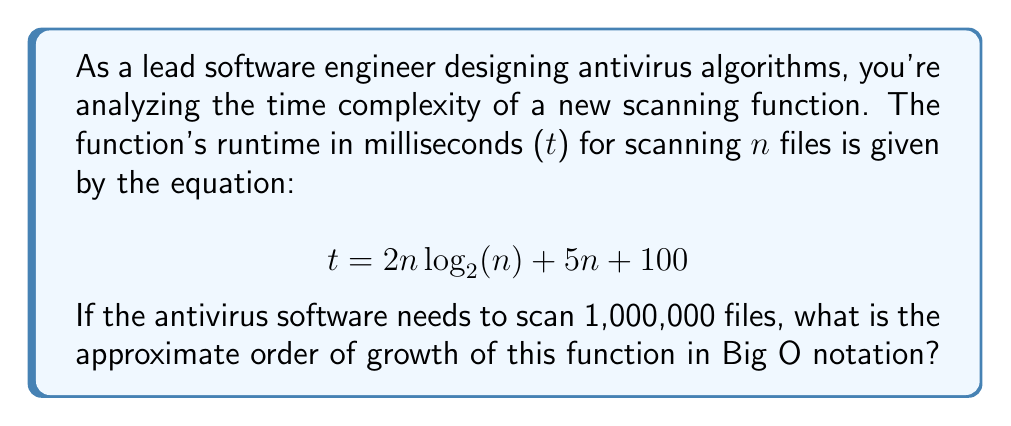Give your solution to this math problem. To determine the order of growth in Big O notation, we need to identify the dominant term in the given function as n approaches infinity. Let's analyze each term:

1. $2n \log_2(n)$
2. $5n$
3. $100$

As n grows large:
- The constant term 100 becomes negligible.
- $5n$ grows linearly.
- $2n \log_2(n)$ grows faster than linear but slower than quadratic.

The dominant term is $2n \log_2(n)$, as it grows faster than the linear term $5n$ for large n.

In Big O notation, we drop constant factors and lower-order terms. Therefore:

$t = 2n \log_2(n) + 5n + 100$ simplifies to $O(n \log n)$

To verify this for the given input size:

Let $n = 1,000,000$

$2n \log_2(n) = 2 \cdot 1,000,000 \cdot \log_2(1,000,000) \approx 39,863,137$
$5n = 5 \cdot 1,000,000 = 5,000,000$
$100$ is negligible

The $2n \log_2(n)$ term is clearly dominant for this large input size, confirming our Big O analysis.
Answer: $O(n \log n)$ 